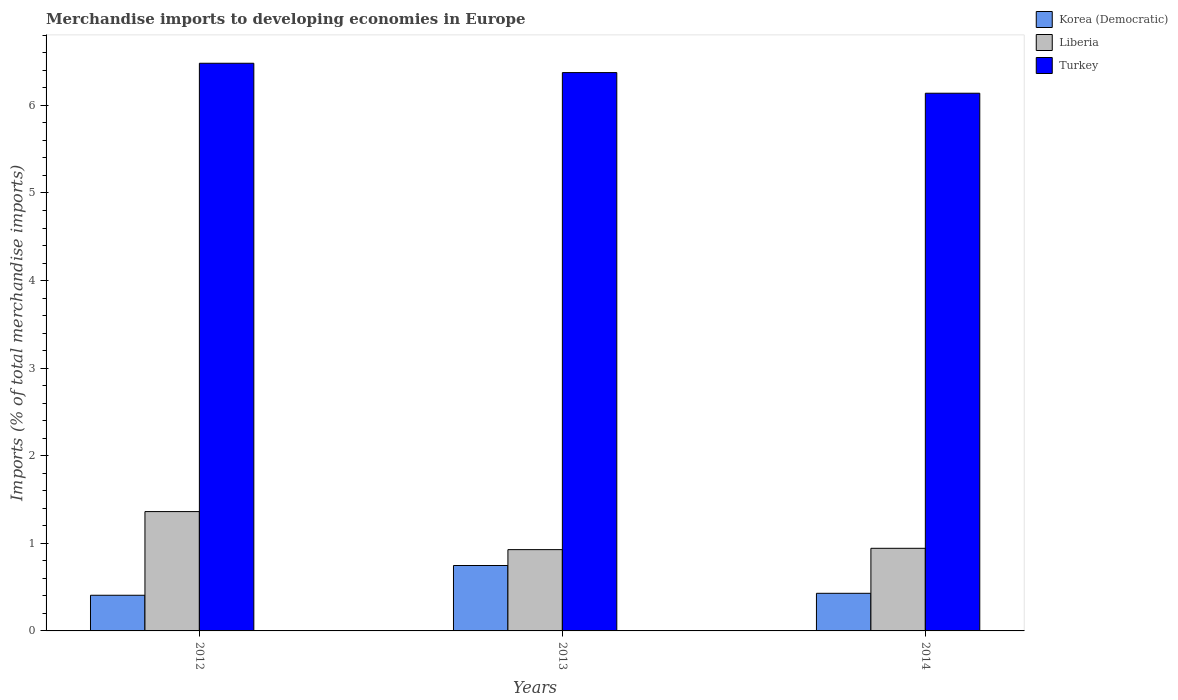How many groups of bars are there?
Offer a terse response. 3. Are the number of bars on each tick of the X-axis equal?
Provide a short and direct response. Yes. How many bars are there on the 3rd tick from the right?
Your response must be concise. 3. What is the label of the 2nd group of bars from the left?
Offer a terse response. 2013. What is the percentage total merchandise imports in Turkey in 2013?
Give a very brief answer. 6.37. Across all years, what is the maximum percentage total merchandise imports in Turkey?
Keep it short and to the point. 6.48. Across all years, what is the minimum percentage total merchandise imports in Liberia?
Give a very brief answer. 0.93. In which year was the percentage total merchandise imports in Liberia maximum?
Your answer should be very brief. 2012. What is the total percentage total merchandise imports in Turkey in the graph?
Your answer should be compact. 18.99. What is the difference between the percentage total merchandise imports in Liberia in 2013 and that in 2014?
Keep it short and to the point. -0.02. What is the difference between the percentage total merchandise imports in Korea (Democratic) in 2014 and the percentage total merchandise imports in Turkey in 2013?
Provide a short and direct response. -5.95. What is the average percentage total merchandise imports in Turkey per year?
Your answer should be compact. 6.33. In the year 2014, what is the difference between the percentage total merchandise imports in Liberia and percentage total merchandise imports in Korea (Democratic)?
Give a very brief answer. 0.51. In how many years, is the percentage total merchandise imports in Korea (Democratic) greater than 5.2 %?
Keep it short and to the point. 0. What is the ratio of the percentage total merchandise imports in Liberia in 2012 to that in 2014?
Your response must be concise. 1.44. Is the difference between the percentage total merchandise imports in Liberia in 2012 and 2013 greater than the difference between the percentage total merchandise imports in Korea (Democratic) in 2012 and 2013?
Provide a succinct answer. Yes. What is the difference between the highest and the second highest percentage total merchandise imports in Korea (Democratic)?
Provide a succinct answer. 0.32. What is the difference between the highest and the lowest percentage total merchandise imports in Korea (Democratic)?
Give a very brief answer. 0.34. What does the 2nd bar from the left in 2013 represents?
Provide a succinct answer. Liberia. What does the 3rd bar from the right in 2012 represents?
Offer a terse response. Korea (Democratic). Is it the case that in every year, the sum of the percentage total merchandise imports in Turkey and percentage total merchandise imports in Liberia is greater than the percentage total merchandise imports in Korea (Democratic)?
Your answer should be very brief. Yes. How many bars are there?
Provide a succinct answer. 9. Are all the bars in the graph horizontal?
Provide a short and direct response. No. How many years are there in the graph?
Offer a terse response. 3. What is the difference between two consecutive major ticks on the Y-axis?
Keep it short and to the point. 1. Are the values on the major ticks of Y-axis written in scientific E-notation?
Ensure brevity in your answer.  No. Where does the legend appear in the graph?
Provide a short and direct response. Top right. How are the legend labels stacked?
Make the answer very short. Vertical. What is the title of the graph?
Your answer should be very brief. Merchandise imports to developing economies in Europe. Does "Peru" appear as one of the legend labels in the graph?
Your answer should be very brief. No. What is the label or title of the Y-axis?
Your answer should be compact. Imports (% of total merchandise imports). What is the Imports (% of total merchandise imports) in Korea (Democratic) in 2012?
Provide a short and direct response. 0.41. What is the Imports (% of total merchandise imports) of Liberia in 2012?
Offer a terse response. 1.36. What is the Imports (% of total merchandise imports) of Turkey in 2012?
Your answer should be compact. 6.48. What is the Imports (% of total merchandise imports) of Korea (Democratic) in 2013?
Offer a very short reply. 0.75. What is the Imports (% of total merchandise imports) of Liberia in 2013?
Ensure brevity in your answer.  0.93. What is the Imports (% of total merchandise imports) of Turkey in 2013?
Provide a short and direct response. 6.37. What is the Imports (% of total merchandise imports) in Korea (Democratic) in 2014?
Give a very brief answer. 0.43. What is the Imports (% of total merchandise imports) in Liberia in 2014?
Offer a very short reply. 0.94. What is the Imports (% of total merchandise imports) of Turkey in 2014?
Offer a terse response. 6.14. Across all years, what is the maximum Imports (% of total merchandise imports) in Korea (Democratic)?
Offer a very short reply. 0.75. Across all years, what is the maximum Imports (% of total merchandise imports) in Liberia?
Your answer should be compact. 1.36. Across all years, what is the maximum Imports (% of total merchandise imports) of Turkey?
Offer a very short reply. 6.48. Across all years, what is the minimum Imports (% of total merchandise imports) in Korea (Democratic)?
Make the answer very short. 0.41. Across all years, what is the minimum Imports (% of total merchandise imports) in Liberia?
Offer a terse response. 0.93. Across all years, what is the minimum Imports (% of total merchandise imports) in Turkey?
Provide a short and direct response. 6.14. What is the total Imports (% of total merchandise imports) of Korea (Democratic) in the graph?
Provide a short and direct response. 1.58. What is the total Imports (% of total merchandise imports) of Liberia in the graph?
Your answer should be very brief. 3.23. What is the total Imports (% of total merchandise imports) in Turkey in the graph?
Ensure brevity in your answer.  18.99. What is the difference between the Imports (% of total merchandise imports) in Korea (Democratic) in 2012 and that in 2013?
Provide a succinct answer. -0.34. What is the difference between the Imports (% of total merchandise imports) in Liberia in 2012 and that in 2013?
Provide a short and direct response. 0.43. What is the difference between the Imports (% of total merchandise imports) of Turkey in 2012 and that in 2013?
Provide a succinct answer. 0.11. What is the difference between the Imports (% of total merchandise imports) of Korea (Democratic) in 2012 and that in 2014?
Offer a terse response. -0.02. What is the difference between the Imports (% of total merchandise imports) in Liberia in 2012 and that in 2014?
Your response must be concise. 0.42. What is the difference between the Imports (% of total merchandise imports) in Turkey in 2012 and that in 2014?
Give a very brief answer. 0.34. What is the difference between the Imports (% of total merchandise imports) in Korea (Democratic) in 2013 and that in 2014?
Keep it short and to the point. 0.32. What is the difference between the Imports (% of total merchandise imports) of Liberia in 2013 and that in 2014?
Make the answer very short. -0.02. What is the difference between the Imports (% of total merchandise imports) in Turkey in 2013 and that in 2014?
Provide a short and direct response. 0.24. What is the difference between the Imports (% of total merchandise imports) of Korea (Democratic) in 2012 and the Imports (% of total merchandise imports) of Liberia in 2013?
Provide a succinct answer. -0.52. What is the difference between the Imports (% of total merchandise imports) of Korea (Democratic) in 2012 and the Imports (% of total merchandise imports) of Turkey in 2013?
Offer a terse response. -5.97. What is the difference between the Imports (% of total merchandise imports) of Liberia in 2012 and the Imports (% of total merchandise imports) of Turkey in 2013?
Your answer should be compact. -5.01. What is the difference between the Imports (% of total merchandise imports) in Korea (Democratic) in 2012 and the Imports (% of total merchandise imports) in Liberia in 2014?
Your answer should be compact. -0.54. What is the difference between the Imports (% of total merchandise imports) of Korea (Democratic) in 2012 and the Imports (% of total merchandise imports) of Turkey in 2014?
Offer a very short reply. -5.73. What is the difference between the Imports (% of total merchandise imports) in Liberia in 2012 and the Imports (% of total merchandise imports) in Turkey in 2014?
Make the answer very short. -4.78. What is the difference between the Imports (% of total merchandise imports) of Korea (Democratic) in 2013 and the Imports (% of total merchandise imports) of Liberia in 2014?
Your answer should be very brief. -0.2. What is the difference between the Imports (% of total merchandise imports) of Korea (Democratic) in 2013 and the Imports (% of total merchandise imports) of Turkey in 2014?
Your response must be concise. -5.39. What is the difference between the Imports (% of total merchandise imports) in Liberia in 2013 and the Imports (% of total merchandise imports) in Turkey in 2014?
Provide a succinct answer. -5.21. What is the average Imports (% of total merchandise imports) of Korea (Democratic) per year?
Make the answer very short. 0.53. What is the average Imports (% of total merchandise imports) of Liberia per year?
Give a very brief answer. 1.08. What is the average Imports (% of total merchandise imports) of Turkey per year?
Ensure brevity in your answer.  6.33. In the year 2012, what is the difference between the Imports (% of total merchandise imports) of Korea (Democratic) and Imports (% of total merchandise imports) of Liberia?
Keep it short and to the point. -0.96. In the year 2012, what is the difference between the Imports (% of total merchandise imports) in Korea (Democratic) and Imports (% of total merchandise imports) in Turkey?
Offer a terse response. -6.07. In the year 2012, what is the difference between the Imports (% of total merchandise imports) of Liberia and Imports (% of total merchandise imports) of Turkey?
Your answer should be very brief. -5.12. In the year 2013, what is the difference between the Imports (% of total merchandise imports) in Korea (Democratic) and Imports (% of total merchandise imports) in Liberia?
Keep it short and to the point. -0.18. In the year 2013, what is the difference between the Imports (% of total merchandise imports) in Korea (Democratic) and Imports (% of total merchandise imports) in Turkey?
Make the answer very short. -5.63. In the year 2013, what is the difference between the Imports (% of total merchandise imports) in Liberia and Imports (% of total merchandise imports) in Turkey?
Provide a short and direct response. -5.45. In the year 2014, what is the difference between the Imports (% of total merchandise imports) in Korea (Democratic) and Imports (% of total merchandise imports) in Liberia?
Make the answer very short. -0.51. In the year 2014, what is the difference between the Imports (% of total merchandise imports) of Korea (Democratic) and Imports (% of total merchandise imports) of Turkey?
Provide a short and direct response. -5.71. In the year 2014, what is the difference between the Imports (% of total merchandise imports) in Liberia and Imports (% of total merchandise imports) in Turkey?
Your answer should be very brief. -5.2. What is the ratio of the Imports (% of total merchandise imports) of Korea (Democratic) in 2012 to that in 2013?
Offer a terse response. 0.55. What is the ratio of the Imports (% of total merchandise imports) of Liberia in 2012 to that in 2013?
Your answer should be very brief. 1.47. What is the ratio of the Imports (% of total merchandise imports) in Turkey in 2012 to that in 2013?
Give a very brief answer. 1.02. What is the ratio of the Imports (% of total merchandise imports) of Korea (Democratic) in 2012 to that in 2014?
Offer a terse response. 0.95. What is the ratio of the Imports (% of total merchandise imports) of Liberia in 2012 to that in 2014?
Give a very brief answer. 1.44. What is the ratio of the Imports (% of total merchandise imports) in Turkey in 2012 to that in 2014?
Your response must be concise. 1.06. What is the ratio of the Imports (% of total merchandise imports) of Korea (Democratic) in 2013 to that in 2014?
Your response must be concise. 1.74. What is the ratio of the Imports (% of total merchandise imports) in Liberia in 2013 to that in 2014?
Your response must be concise. 0.98. What is the ratio of the Imports (% of total merchandise imports) in Turkey in 2013 to that in 2014?
Give a very brief answer. 1.04. What is the difference between the highest and the second highest Imports (% of total merchandise imports) of Korea (Democratic)?
Your response must be concise. 0.32. What is the difference between the highest and the second highest Imports (% of total merchandise imports) of Liberia?
Make the answer very short. 0.42. What is the difference between the highest and the second highest Imports (% of total merchandise imports) of Turkey?
Ensure brevity in your answer.  0.11. What is the difference between the highest and the lowest Imports (% of total merchandise imports) of Korea (Democratic)?
Ensure brevity in your answer.  0.34. What is the difference between the highest and the lowest Imports (% of total merchandise imports) of Liberia?
Ensure brevity in your answer.  0.43. What is the difference between the highest and the lowest Imports (% of total merchandise imports) in Turkey?
Give a very brief answer. 0.34. 